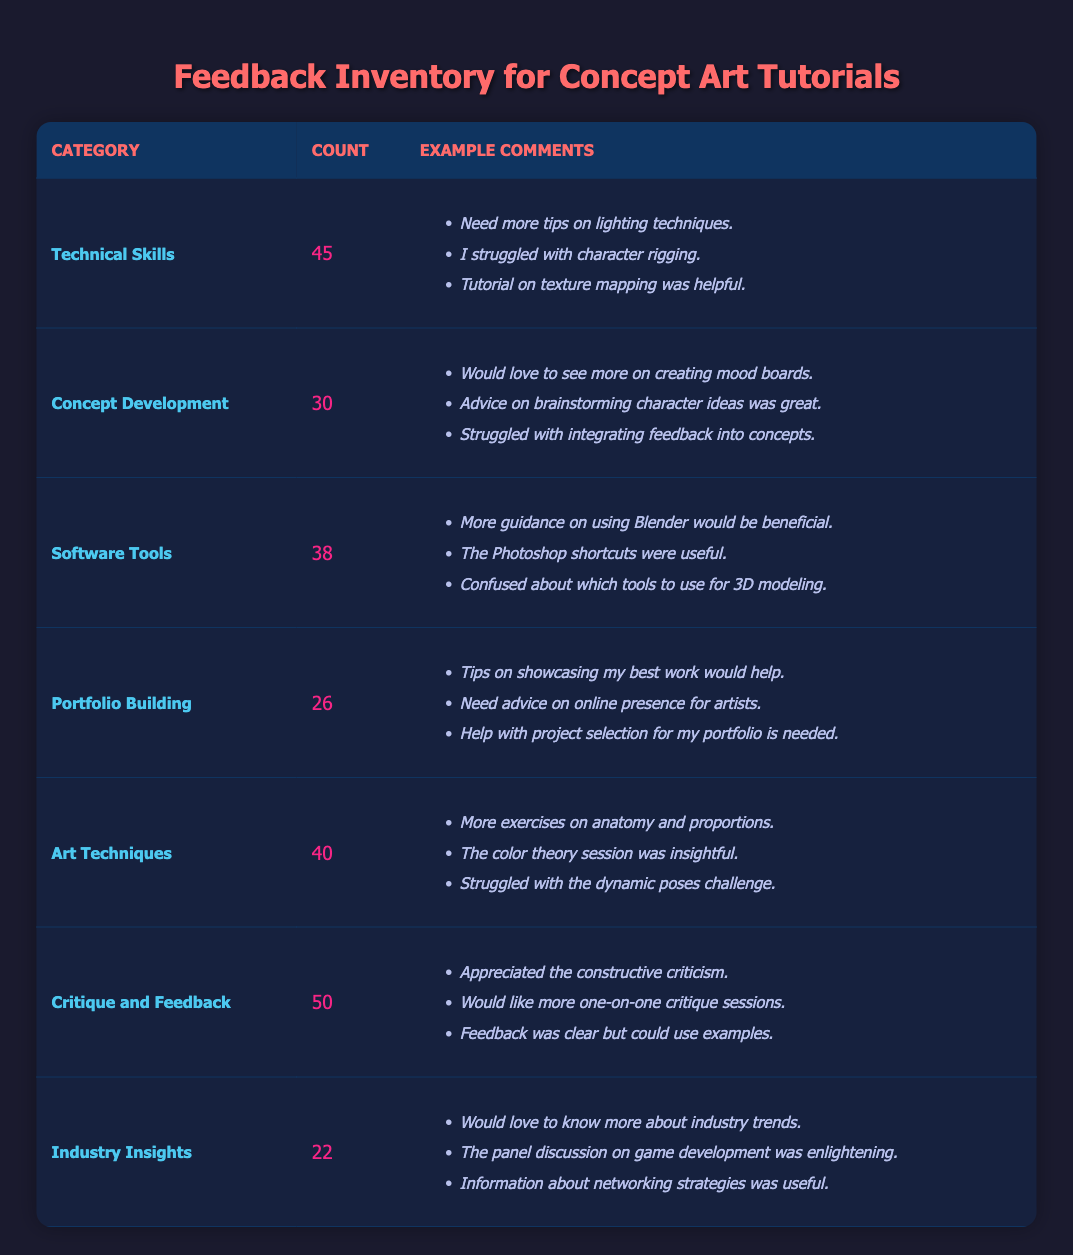What is the category with the highest number of feedback comments? The table shows that "Critique and Feedback" has the highest count of 50, which indicates it's the most commented category.
Answer: Critique and Feedback How many feedback comments were received about "Software Tools"? The count column for "Software Tools" shows 38 comments were received.
Answer: 38 What is the total number of feedback comments across all categories? To find the total, we add the counts: 45 + 30 + 38 + 26 + 40 + 50 + 22 = 251.
Answer: 251 Is the number of feedback comments for "Concept Development" greater than that for "Portfolio Building"? The count for "Concept Development" is 30, while for "Portfolio Building" it is 26, so 30 is greater than 26.
Answer: Yes What is the average number of feedback comments per category? There are 7 categories: (45 + 30 + 38 + 26 + 40 + 50 + 22) = 251 total comments, so the average is 251 / 7, which equals approximately 35.86.
Answer: 35.86 Which category has the least number of feedback comments? The table indicates that "Industry Insights" has the lowest count at 22 comments, making it the least commented category.
Answer: Industry Insights Is "Technical Skills" the category with the most comments? Comparing the counts, "Technical Skills" has 45 comments, whereas "Critique and Feedback" has more at 50. Thus, it is not the most.
Answer: No How many more comments did "Art Techniques" receive compared to "Portfolio Building"? "Art Techniques" has 40 comments and "Portfolio Building" has 26. The difference is 40 - 26 = 14.
Answer: 14 What percentage of the total comments fall under "Feedback and Critique"? "Critique and Feedback" has 50 comments. To find the percentage, we calculate (50 / 251) * 100, which is approximately 19.92%.
Answer: 19.92% 